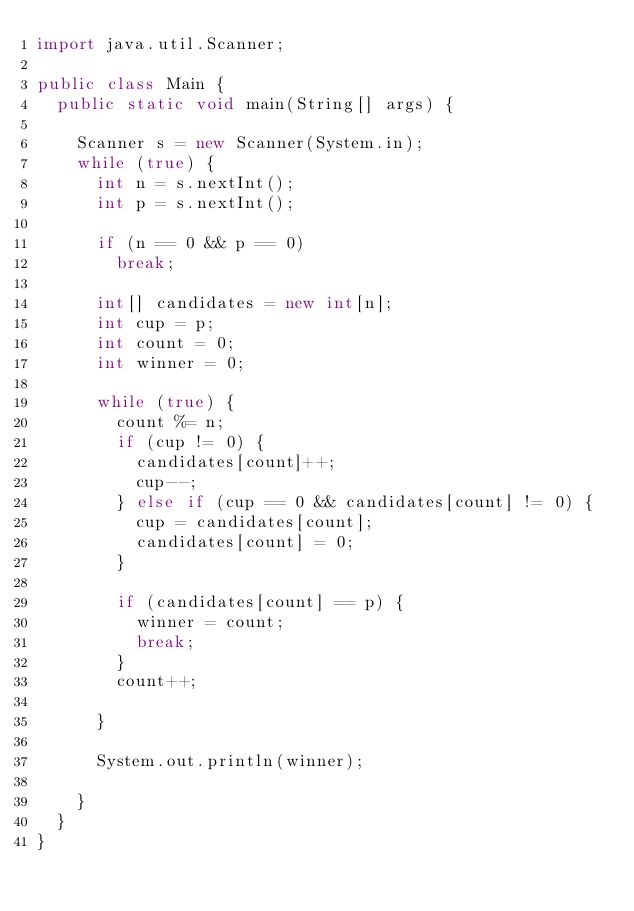Convert code to text. <code><loc_0><loc_0><loc_500><loc_500><_Java_>import java.util.Scanner;

public class Main {
	public static void main(String[] args) {

		Scanner s = new Scanner(System.in);
		while (true) {
			int n = s.nextInt();
			int p = s.nextInt();

			if (n == 0 && p == 0)
				break;

			int[] candidates = new int[n];
			int cup = p;
			int count = 0;
			int winner = 0;

			while (true) {
				count %= n;
				if (cup != 0) {
					candidates[count]++;
					cup--;
				} else if (cup == 0 && candidates[count] != 0) {
					cup = candidates[count];
					candidates[count] = 0;
				}

				if (candidates[count] == p) {
					winner = count;
					break;
				}
				count++;

			}

			System.out.println(winner);

		}
	}
}</code> 